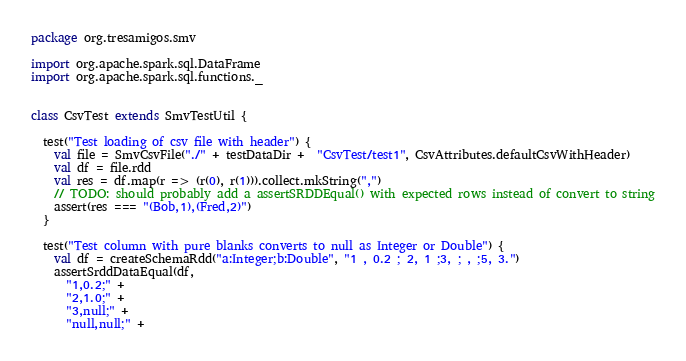Convert code to text. <code><loc_0><loc_0><loc_500><loc_500><_Scala_>package org.tresamigos.smv

import org.apache.spark.sql.DataFrame
import org.apache.spark.sql.functions._


class CsvTest extends SmvTestUtil {

  test("Test loading of csv file with header") {
    val file = SmvCsvFile("./" + testDataDir +  "CsvTest/test1", CsvAttributes.defaultCsvWithHeader)
    val df = file.rdd
    val res = df.map(r => (r(0), r(1))).collect.mkString(",")
    // TODO: should probably add a assertSRDDEqual() with expected rows instead of convert to string
    assert(res === "(Bob,1),(Fred,2)")
  }

  test("Test column with pure blanks converts to null as Integer or Double") {
    val df = createSchemaRdd("a:Integer;b:Double", "1 , 0.2 ; 2, 1 ;3, ; , ;5, 3.")
    assertSrddDataEqual(df,
      "1,0.2;" +
      "2,1.0;" +
      "3,null;" +
      "null,null;" +</code> 